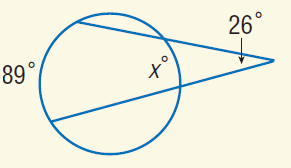Answer the mathemtical geometry problem and directly provide the correct option letter.
Question: Find x.
Choices: A: 26 B: 37 C: 80 D: 89 B 